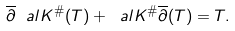Convert formula to latex. <formula><loc_0><loc_0><loc_500><loc_500>\overline { \partial } \ a l K ^ { \# } ( T ) + \ a l K ^ { \# } \overline { \partial } ( T ) = T .</formula> 